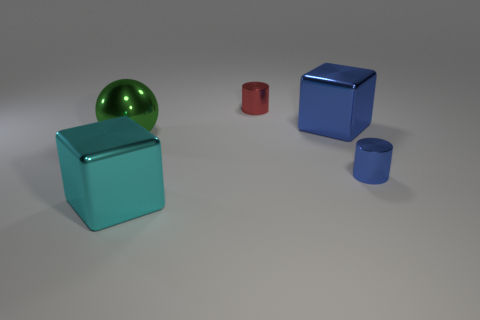Add 2 cyan blocks. How many objects exist? 7 Subtract all blue cylinders. How many cylinders are left? 1 Subtract all brown cylinders. Subtract all brown balls. How many cylinders are left? 2 Subtract all tiny blue cylinders. Subtract all large brown rubber blocks. How many objects are left? 4 Add 1 metal things. How many metal things are left? 6 Add 1 tiny red metal objects. How many tiny red metal objects exist? 2 Subtract 0 yellow blocks. How many objects are left? 5 Subtract all cubes. How many objects are left? 3 